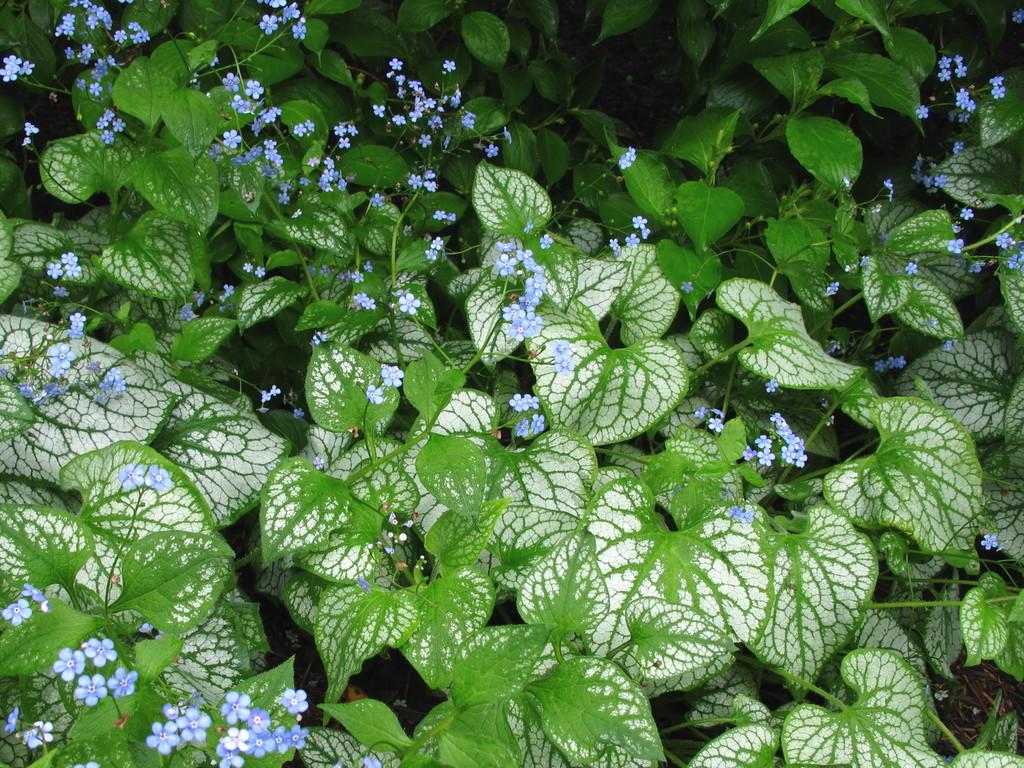What is the main subject of the image? The main subject of the image is a group of plants. What can be observed about the plants in the image? The plants have flowers. What type of agreement is being discussed by the duck in the image? There is no duck present in the image, so no agreement can be discussed. 